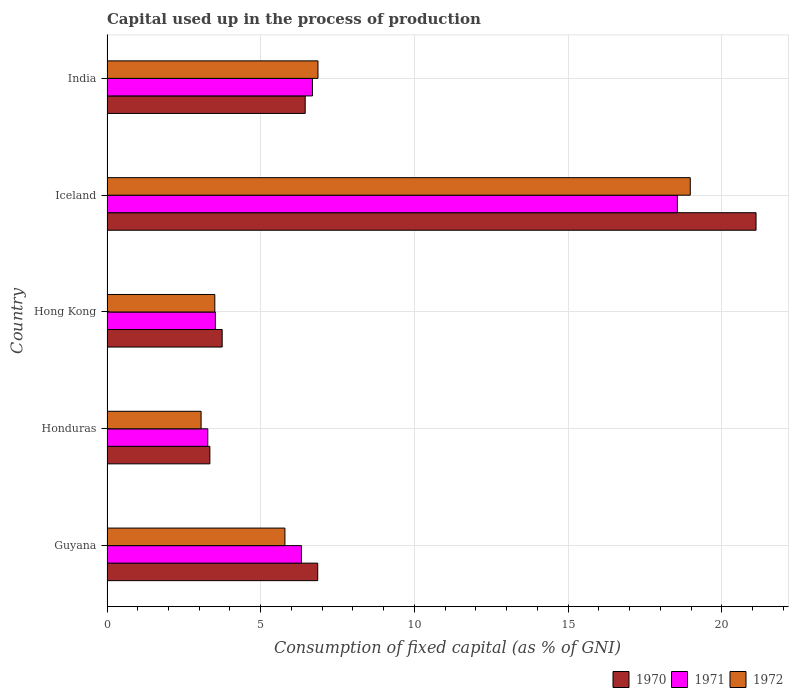How many different coloured bars are there?
Give a very brief answer. 3. Are the number of bars per tick equal to the number of legend labels?
Provide a succinct answer. Yes. What is the label of the 3rd group of bars from the top?
Make the answer very short. Hong Kong. In how many cases, is the number of bars for a given country not equal to the number of legend labels?
Provide a succinct answer. 0. What is the capital used up in the process of production in 1971 in India?
Your response must be concise. 6.68. Across all countries, what is the maximum capital used up in the process of production in 1971?
Your answer should be very brief. 18.55. Across all countries, what is the minimum capital used up in the process of production in 1972?
Ensure brevity in your answer.  3.06. In which country was the capital used up in the process of production in 1972 maximum?
Give a very brief answer. Iceland. In which country was the capital used up in the process of production in 1972 minimum?
Offer a very short reply. Honduras. What is the total capital used up in the process of production in 1971 in the graph?
Provide a succinct answer. 38.36. What is the difference between the capital used up in the process of production in 1970 in Hong Kong and that in India?
Your answer should be compact. -2.7. What is the difference between the capital used up in the process of production in 1972 in Honduras and the capital used up in the process of production in 1970 in Iceland?
Offer a very short reply. -18.05. What is the average capital used up in the process of production in 1970 per country?
Provide a short and direct response. 8.3. What is the difference between the capital used up in the process of production in 1970 and capital used up in the process of production in 1972 in Iceland?
Offer a terse response. 2.14. What is the ratio of the capital used up in the process of production in 1972 in Iceland to that in India?
Offer a very short reply. 2.76. What is the difference between the highest and the second highest capital used up in the process of production in 1972?
Keep it short and to the point. 12.11. What is the difference between the highest and the lowest capital used up in the process of production in 1972?
Offer a terse response. 15.91. Is the sum of the capital used up in the process of production in 1971 in Honduras and Iceland greater than the maximum capital used up in the process of production in 1970 across all countries?
Offer a very short reply. Yes. What does the 3rd bar from the top in Honduras represents?
Offer a very short reply. 1970. Is it the case that in every country, the sum of the capital used up in the process of production in 1972 and capital used up in the process of production in 1971 is greater than the capital used up in the process of production in 1970?
Offer a very short reply. Yes. Are all the bars in the graph horizontal?
Your answer should be very brief. Yes. What is the difference between two consecutive major ticks on the X-axis?
Ensure brevity in your answer.  5. Are the values on the major ticks of X-axis written in scientific E-notation?
Provide a succinct answer. No. Does the graph contain any zero values?
Provide a succinct answer. No. How many legend labels are there?
Give a very brief answer. 3. What is the title of the graph?
Keep it short and to the point. Capital used up in the process of production. What is the label or title of the X-axis?
Give a very brief answer. Consumption of fixed capital (as % of GNI). What is the label or title of the Y-axis?
Provide a short and direct response. Country. What is the Consumption of fixed capital (as % of GNI) in 1970 in Guyana?
Keep it short and to the point. 6.85. What is the Consumption of fixed capital (as % of GNI) of 1971 in Guyana?
Your answer should be compact. 6.32. What is the Consumption of fixed capital (as % of GNI) in 1972 in Guyana?
Your answer should be compact. 5.79. What is the Consumption of fixed capital (as % of GNI) of 1970 in Honduras?
Make the answer very short. 3.35. What is the Consumption of fixed capital (as % of GNI) of 1971 in Honduras?
Your answer should be very brief. 3.28. What is the Consumption of fixed capital (as % of GNI) of 1972 in Honduras?
Your response must be concise. 3.06. What is the Consumption of fixed capital (as % of GNI) in 1970 in Hong Kong?
Provide a short and direct response. 3.75. What is the Consumption of fixed capital (as % of GNI) of 1971 in Hong Kong?
Offer a terse response. 3.52. What is the Consumption of fixed capital (as % of GNI) of 1972 in Hong Kong?
Offer a terse response. 3.51. What is the Consumption of fixed capital (as % of GNI) in 1970 in Iceland?
Make the answer very short. 21.11. What is the Consumption of fixed capital (as % of GNI) in 1971 in Iceland?
Keep it short and to the point. 18.55. What is the Consumption of fixed capital (as % of GNI) of 1972 in Iceland?
Your answer should be very brief. 18.97. What is the Consumption of fixed capital (as % of GNI) of 1970 in India?
Your answer should be very brief. 6.45. What is the Consumption of fixed capital (as % of GNI) in 1971 in India?
Offer a very short reply. 6.68. What is the Consumption of fixed capital (as % of GNI) of 1972 in India?
Your answer should be very brief. 6.86. Across all countries, what is the maximum Consumption of fixed capital (as % of GNI) in 1970?
Your answer should be very brief. 21.11. Across all countries, what is the maximum Consumption of fixed capital (as % of GNI) of 1971?
Keep it short and to the point. 18.55. Across all countries, what is the maximum Consumption of fixed capital (as % of GNI) in 1972?
Offer a very short reply. 18.97. Across all countries, what is the minimum Consumption of fixed capital (as % of GNI) in 1970?
Your answer should be very brief. 3.35. Across all countries, what is the minimum Consumption of fixed capital (as % of GNI) of 1971?
Your answer should be very brief. 3.28. Across all countries, what is the minimum Consumption of fixed capital (as % of GNI) of 1972?
Ensure brevity in your answer.  3.06. What is the total Consumption of fixed capital (as % of GNI) of 1970 in the graph?
Provide a succinct answer. 41.51. What is the total Consumption of fixed capital (as % of GNI) of 1971 in the graph?
Make the answer very short. 38.36. What is the total Consumption of fixed capital (as % of GNI) in 1972 in the graph?
Provide a succinct answer. 38.19. What is the difference between the Consumption of fixed capital (as % of GNI) of 1970 in Guyana and that in Honduras?
Provide a short and direct response. 3.51. What is the difference between the Consumption of fixed capital (as % of GNI) in 1971 in Guyana and that in Honduras?
Your answer should be very brief. 3.05. What is the difference between the Consumption of fixed capital (as % of GNI) in 1972 in Guyana and that in Honduras?
Offer a terse response. 2.73. What is the difference between the Consumption of fixed capital (as % of GNI) of 1970 in Guyana and that in Hong Kong?
Give a very brief answer. 3.11. What is the difference between the Consumption of fixed capital (as % of GNI) of 1971 in Guyana and that in Hong Kong?
Your response must be concise. 2.8. What is the difference between the Consumption of fixed capital (as % of GNI) in 1972 in Guyana and that in Hong Kong?
Your answer should be compact. 2.28. What is the difference between the Consumption of fixed capital (as % of GNI) of 1970 in Guyana and that in Iceland?
Give a very brief answer. -14.26. What is the difference between the Consumption of fixed capital (as % of GNI) in 1971 in Guyana and that in Iceland?
Your response must be concise. -12.23. What is the difference between the Consumption of fixed capital (as % of GNI) in 1972 in Guyana and that in Iceland?
Ensure brevity in your answer.  -13.19. What is the difference between the Consumption of fixed capital (as % of GNI) in 1970 in Guyana and that in India?
Provide a succinct answer. 0.41. What is the difference between the Consumption of fixed capital (as % of GNI) of 1971 in Guyana and that in India?
Your answer should be compact. -0.36. What is the difference between the Consumption of fixed capital (as % of GNI) in 1972 in Guyana and that in India?
Give a very brief answer. -1.08. What is the difference between the Consumption of fixed capital (as % of GNI) of 1970 in Honduras and that in Hong Kong?
Offer a very short reply. -0.4. What is the difference between the Consumption of fixed capital (as % of GNI) in 1971 in Honduras and that in Hong Kong?
Make the answer very short. -0.25. What is the difference between the Consumption of fixed capital (as % of GNI) of 1972 in Honduras and that in Hong Kong?
Make the answer very short. -0.45. What is the difference between the Consumption of fixed capital (as % of GNI) in 1970 in Honduras and that in Iceland?
Offer a terse response. -17.77. What is the difference between the Consumption of fixed capital (as % of GNI) in 1971 in Honduras and that in Iceland?
Make the answer very short. -15.27. What is the difference between the Consumption of fixed capital (as % of GNI) in 1972 in Honduras and that in Iceland?
Offer a terse response. -15.91. What is the difference between the Consumption of fixed capital (as % of GNI) in 1970 in Honduras and that in India?
Ensure brevity in your answer.  -3.1. What is the difference between the Consumption of fixed capital (as % of GNI) in 1971 in Honduras and that in India?
Keep it short and to the point. -3.4. What is the difference between the Consumption of fixed capital (as % of GNI) of 1972 in Honduras and that in India?
Provide a succinct answer. -3.8. What is the difference between the Consumption of fixed capital (as % of GNI) in 1970 in Hong Kong and that in Iceland?
Your answer should be very brief. -17.37. What is the difference between the Consumption of fixed capital (as % of GNI) in 1971 in Hong Kong and that in Iceland?
Provide a succinct answer. -15.03. What is the difference between the Consumption of fixed capital (as % of GNI) of 1972 in Hong Kong and that in Iceland?
Your answer should be compact. -15.47. What is the difference between the Consumption of fixed capital (as % of GNI) in 1970 in Hong Kong and that in India?
Ensure brevity in your answer.  -2.7. What is the difference between the Consumption of fixed capital (as % of GNI) in 1971 in Hong Kong and that in India?
Your answer should be very brief. -3.16. What is the difference between the Consumption of fixed capital (as % of GNI) of 1972 in Hong Kong and that in India?
Offer a very short reply. -3.36. What is the difference between the Consumption of fixed capital (as % of GNI) in 1970 in Iceland and that in India?
Offer a terse response. 14.67. What is the difference between the Consumption of fixed capital (as % of GNI) in 1971 in Iceland and that in India?
Your answer should be compact. 11.87. What is the difference between the Consumption of fixed capital (as % of GNI) in 1972 in Iceland and that in India?
Offer a terse response. 12.11. What is the difference between the Consumption of fixed capital (as % of GNI) of 1970 in Guyana and the Consumption of fixed capital (as % of GNI) of 1971 in Honduras?
Offer a very short reply. 3.58. What is the difference between the Consumption of fixed capital (as % of GNI) of 1970 in Guyana and the Consumption of fixed capital (as % of GNI) of 1972 in Honduras?
Offer a terse response. 3.79. What is the difference between the Consumption of fixed capital (as % of GNI) of 1971 in Guyana and the Consumption of fixed capital (as % of GNI) of 1972 in Honduras?
Give a very brief answer. 3.26. What is the difference between the Consumption of fixed capital (as % of GNI) of 1970 in Guyana and the Consumption of fixed capital (as % of GNI) of 1971 in Hong Kong?
Your answer should be compact. 3.33. What is the difference between the Consumption of fixed capital (as % of GNI) of 1970 in Guyana and the Consumption of fixed capital (as % of GNI) of 1972 in Hong Kong?
Keep it short and to the point. 3.35. What is the difference between the Consumption of fixed capital (as % of GNI) of 1971 in Guyana and the Consumption of fixed capital (as % of GNI) of 1972 in Hong Kong?
Provide a succinct answer. 2.82. What is the difference between the Consumption of fixed capital (as % of GNI) in 1970 in Guyana and the Consumption of fixed capital (as % of GNI) in 1971 in Iceland?
Provide a short and direct response. -11.7. What is the difference between the Consumption of fixed capital (as % of GNI) of 1970 in Guyana and the Consumption of fixed capital (as % of GNI) of 1972 in Iceland?
Make the answer very short. -12.12. What is the difference between the Consumption of fixed capital (as % of GNI) in 1971 in Guyana and the Consumption of fixed capital (as % of GNI) in 1972 in Iceland?
Offer a terse response. -12.65. What is the difference between the Consumption of fixed capital (as % of GNI) of 1970 in Guyana and the Consumption of fixed capital (as % of GNI) of 1971 in India?
Offer a terse response. 0.17. What is the difference between the Consumption of fixed capital (as % of GNI) of 1970 in Guyana and the Consumption of fixed capital (as % of GNI) of 1972 in India?
Provide a succinct answer. -0.01. What is the difference between the Consumption of fixed capital (as % of GNI) of 1971 in Guyana and the Consumption of fixed capital (as % of GNI) of 1972 in India?
Provide a short and direct response. -0.54. What is the difference between the Consumption of fixed capital (as % of GNI) in 1970 in Honduras and the Consumption of fixed capital (as % of GNI) in 1971 in Hong Kong?
Your response must be concise. -0.18. What is the difference between the Consumption of fixed capital (as % of GNI) of 1970 in Honduras and the Consumption of fixed capital (as % of GNI) of 1972 in Hong Kong?
Ensure brevity in your answer.  -0.16. What is the difference between the Consumption of fixed capital (as % of GNI) of 1971 in Honduras and the Consumption of fixed capital (as % of GNI) of 1972 in Hong Kong?
Ensure brevity in your answer.  -0.23. What is the difference between the Consumption of fixed capital (as % of GNI) in 1970 in Honduras and the Consumption of fixed capital (as % of GNI) in 1971 in Iceland?
Give a very brief answer. -15.21. What is the difference between the Consumption of fixed capital (as % of GNI) of 1970 in Honduras and the Consumption of fixed capital (as % of GNI) of 1972 in Iceland?
Your answer should be very brief. -15.63. What is the difference between the Consumption of fixed capital (as % of GNI) of 1971 in Honduras and the Consumption of fixed capital (as % of GNI) of 1972 in Iceland?
Keep it short and to the point. -15.7. What is the difference between the Consumption of fixed capital (as % of GNI) of 1970 in Honduras and the Consumption of fixed capital (as % of GNI) of 1971 in India?
Your answer should be very brief. -3.34. What is the difference between the Consumption of fixed capital (as % of GNI) of 1970 in Honduras and the Consumption of fixed capital (as % of GNI) of 1972 in India?
Ensure brevity in your answer.  -3.52. What is the difference between the Consumption of fixed capital (as % of GNI) in 1971 in Honduras and the Consumption of fixed capital (as % of GNI) in 1972 in India?
Offer a very short reply. -3.58. What is the difference between the Consumption of fixed capital (as % of GNI) in 1970 in Hong Kong and the Consumption of fixed capital (as % of GNI) in 1971 in Iceland?
Your response must be concise. -14.81. What is the difference between the Consumption of fixed capital (as % of GNI) of 1970 in Hong Kong and the Consumption of fixed capital (as % of GNI) of 1972 in Iceland?
Offer a terse response. -15.23. What is the difference between the Consumption of fixed capital (as % of GNI) of 1971 in Hong Kong and the Consumption of fixed capital (as % of GNI) of 1972 in Iceland?
Offer a very short reply. -15.45. What is the difference between the Consumption of fixed capital (as % of GNI) of 1970 in Hong Kong and the Consumption of fixed capital (as % of GNI) of 1971 in India?
Your response must be concise. -2.94. What is the difference between the Consumption of fixed capital (as % of GNI) in 1970 in Hong Kong and the Consumption of fixed capital (as % of GNI) in 1972 in India?
Your answer should be very brief. -3.12. What is the difference between the Consumption of fixed capital (as % of GNI) of 1971 in Hong Kong and the Consumption of fixed capital (as % of GNI) of 1972 in India?
Ensure brevity in your answer.  -3.34. What is the difference between the Consumption of fixed capital (as % of GNI) of 1970 in Iceland and the Consumption of fixed capital (as % of GNI) of 1971 in India?
Offer a terse response. 14.43. What is the difference between the Consumption of fixed capital (as % of GNI) of 1970 in Iceland and the Consumption of fixed capital (as % of GNI) of 1972 in India?
Ensure brevity in your answer.  14.25. What is the difference between the Consumption of fixed capital (as % of GNI) of 1971 in Iceland and the Consumption of fixed capital (as % of GNI) of 1972 in India?
Ensure brevity in your answer.  11.69. What is the average Consumption of fixed capital (as % of GNI) in 1970 per country?
Provide a short and direct response. 8.3. What is the average Consumption of fixed capital (as % of GNI) of 1971 per country?
Ensure brevity in your answer.  7.67. What is the average Consumption of fixed capital (as % of GNI) of 1972 per country?
Your answer should be very brief. 7.64. What is the difference between the Consumption of fixed capital (as % of GNI) of 1970 and Consumption of fixed capital (as % of GNI) of 1971 in Guyana?
Ensure brevity in your answer.  0.53. What is the difference between the Consumption of fixed capital (as % of GNI) of 1970 and Consumption of fixed capital (as % of GNI) of 1972 in Guyana?
Your answer should be very brief. 1.07. What is the difference between the Consumption of fixed capital (as % of GNI) of 1971 and Consumption of fixed capital (as % of GNI) of 1972 in Guyana?
Give a very brief answer. 0.54. What is the difference between the Consumption of fixed capital (as % of GNI) of 1970 and Consumption of fixed capital (as % of GNI) of 1971 in Honduras?
Your response must be concise. 0.07. What is the difference between the Consumption of fixed capital (as % of GNI) in 1970 and Consumption of fixed capital (as % of GNI) in 1972 in Honduras?
Offer a very short reply. 0.29. What is the difference between the Consumption of fixed capital (as % of GNI) of 1971 and Consumption of fixed capital (as % of GNI) of 1972 in Honduras?
Offer a very short reply. 0.22. What is the difference between the Consumption of fixed capital (as % of GNI) in 1970 and Consumption of fixed capital (as % of GNI) in 1971 in Hong Kong?
Offer a very short reply. 0.22. What is the difference between the Consumption of fixed capital (as % of GNI) of 1970 and Consumption of fixed capital (as % of GNI) of 1972 in Hong Kong?
Provide a short and direct response. 0.24. What is the difference between the Consumption of fixed capital (as % of GNI) in 1971 and Consumption of fixed capital (as % of GNI) in 1972 in Hong Kong?
Keep it short and to the point. 0.02. What is the difference between the Consumption of fixed capital (as % of GNI) of 1970 and Consumption of fixed capital (as % of GNI) of 1971 in Iceland?
Your response must be concise. 2.56. What is the difference between the Consumption of fixed capital (as % of GNI) of 1970 and Consumption of fixed capital (as % of GNI) of 1972 in Iceland?
Provide a short and direct response. 2.14. What is the difference between the Consumption of fixed capital (as % of GNI) of 1971 and Consumption of fixed capital (as % of GNI) of 1972 in Iceland?
Provide a succinct answer. -0.42. What is the difference between the Consumption of fixed capital (as % of GNI) in 1970 and Consumption of fixed capital (as % of GNI) in 1971 in India?
Provide a succinct answer. -0.24. What is the difference between the Consumption of fixed capital (as % of GNI) in 1970 and Consumption of fixed capital (as % of GNI) in 1972 in India?
Provide a succinct answer. -0.42. What is the difference between the Consumption of fixed capital (as % of GNI) in 1971 and Consumption of fixed capital (as % of GNI) in 1972 in India?
Your answer should be compact. -0.18. What is the ratio of the Consumption of fixed capital (as % of GNI) of 1970 in Guyana to that in Honduras?
Ensure brevity in your answer.  2.05. What is the ratio of the Consumption of fixed capital (as % of GNI) of 1971 in Guyana to that in Honduras?
Ensure brevity in your answer.  1.93. What is the ratio of the Consumption of fixed capital (as % of GNI) in 1972 in Guyana to that in Honduras?
Give a very brief answer. 1.89. What is the ratio of the Consumption of fixed capital (as % of GNI) in 1970 in Guyana to that in Hong Kong?
Give a very brief answer. 1.83. What is the ratio of the Consumption of fixed capital (as % of GNI) of 1971 in Guyana to that in Hong Kong?
Give a very brief answer. 1.79. What is the ratio of the Consumption of fixed capital (as % of GNI) of 1972 in Guyana to that in Hong Kong?
Your answer should be very brief. 1.65. What is the ratio of the Consumption of fixed capital (as % of GNI) of 1970 in Guyana to that in Iceland?
Provide a succinct answer. 0.32. What is the ratio of the Consumption of fixed capital (as % of GNI) of 1971 in Guyana to that in Iceland?
Ensure brevity in your answer.  0.34. What is the ratio of the Consumption of fixed capital (as % of GNI) of 1972 in Guyana to that in Iceland?
Your answer should be very brief. 0.3. What is the ratio of the Consumption of fixed capital (as % of GNI) of 1970 in Guyana to that in India?
Your answer should be very brief. 1.06. What is the ratio of the Consumption of fixed capital (as % of GNI) of 1971 in Guyana to that in India?
Provide a succinct answer. 0.95. What is the ratio of the Consumption of fixed capital (as % of GNI) of 1972 in Guyana to that in India?
Keep it short and to the point. 0.84. What is the ratio of the Consumption of fixed capital (as % of GNI) of 1970 in Honduras to that in Hong Kong?
Make the answer very short. 0.89. What is the ratio of the Consumption of fixed capital (as % of GNI) in 1971 in Honduras to that in Hong Kong?
Make the answer very short. 0.93. What is the ratio of the Consumption of fixed capital (as % of GNI) of 1972 in Honduras to that in Hong Kong?
Offer a terse response. 0.87. What is the ratio of the Consumption of fixed capital (as % of GNI) in 1970 in Honduras to that in Iceland?
Offer a very short reply. 0.16. What is the ratio of the Consumption of fixed capital (as % of GNI) in 1971 in Honduras to that in Iceland?
Offer a terse response. 0.18. What is the ratio of the Consumption of fixed capital (as % of GNI) of 1972 in Honduras to that in Iceland?
Offer a terse response. 0.16. What is the ratio of the Consumption of fixed capital (as % of GNI) of 1970 in Honduras to that in India?
Your answer should be very brief. 0.52. What is the ratio of the Consumption of fixed capital (as % of GNI) in 1971 in Honduras to that in India?
Ensure brevity in your answer.  0.49. What is the ratio of the Consumption of fixed capital (as % of GNI) of 1972 in Honduras to that in India?
Give a very brief answer. 0.45. What is the ratio of the Consumption of fixed capital (as % of GNI) of 1970 in Hong Kong to that in Iceland?
Keep it short and to the point. 0.18. What is the ratio of the Consumption of fixed capital (as % of GNI) in 1971 in Hong Kong to that in Iceland?
Your answer should be compact. 0.19. What is the ratio of the Consumption of fixed capital (as % of GNI) in 1972 in Hong Kong to that in Iceland?
Your response must be concise. 0.18. What is the ratio of the Consumption of fixed capital (as % of GNI) of 1970 in Hong Kong to that in India?
Give a very brief answer. 0.58. What is the ratio of the Consumption of fixed capital (as % of GNI) of 1971 in Hong Kong to that in India?
Give a very brief answer. 0.53. What is the ratio of the Consumption of fixed capital (as % of GNI) of 1972 in Hong Kong to that in India?
Provide a short and direct response. 0.51. What is the ratio of the Consumption of fixed capital (as % of GNI) in 1970 in Iceland to that in India?
Offer a terse response. 3.27. What is the ratio of the Consumption of fixed capital (as % of GNI) of 1971 in Iceland to that in India?
Keep it short and to the point. 2.78. What is the ratio of the Consumption of fixed capital (as % of GNI) in 1972 in Iceland to that in India?
Offer a terse response. 2.76. What is the difference between the highest and the second highest Consumption of fixed capital (as % of GNI) in 1970?
Give a very brief answer. 14.26. What is the difference between the highest and the second highest Consumption of fixed capital (as % of GNI) in 1971?
Provide a succinct answer. 11.87. What is the difference between the highest and the second highest Consumption of fixed capital (as % of GNI) in 1972?
Your response must be concise. 12.11. What is the difference between the highest and the lowest Consumption of fixed capital (as % of GNI) of 1970?
Provide a succinct answer. 17.77. What is the difference between the highest and the lowest Consumption of fixed capital (as % of GNI) in 1971?
Provide a short and direct response. 15.27. What is the difference between the highest and the lowest Consumption of fixed capital (as % of GNI) in 1972?
Keep it short and to the point. 15.91. 